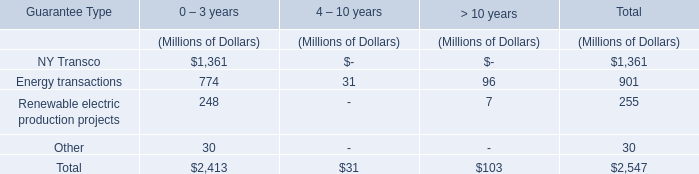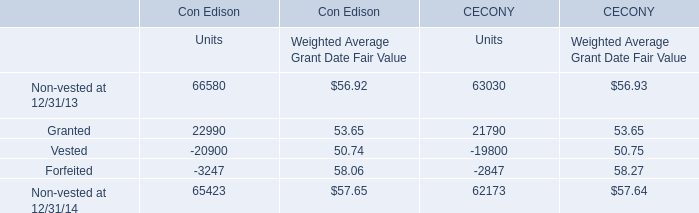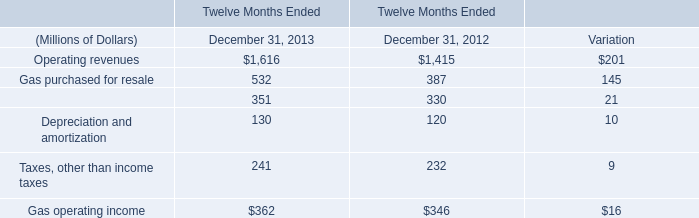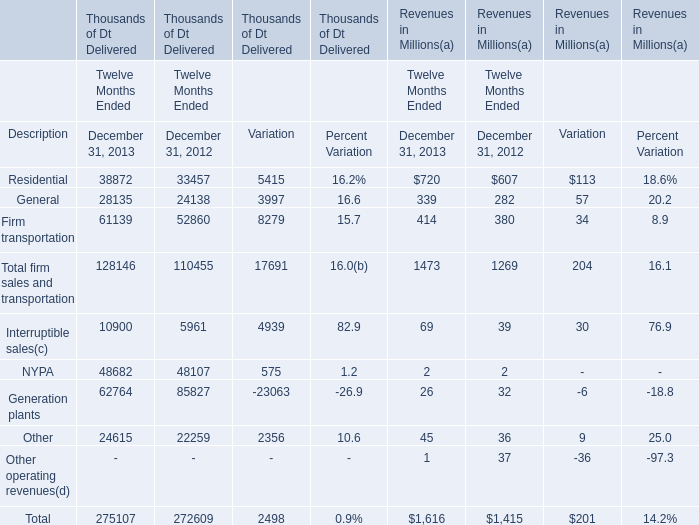what's the total amount of Vested of Con Edison Units, Firm transportation of Thousands of Dt Delivered Variation, and NYPA of Thousands of Dt Delivered Twelve Months Ended December 31, 2013 ? 
Computations: ((20900.0 + 8279.0) + 48682.0)
Answer: 77861.0. 